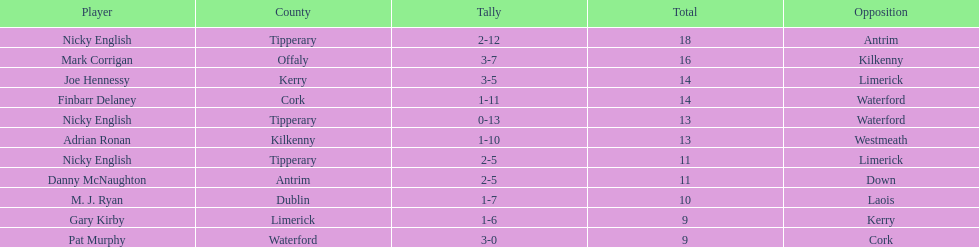What was the mean of the combined sums of nicky english and mark corrigan? 17. 